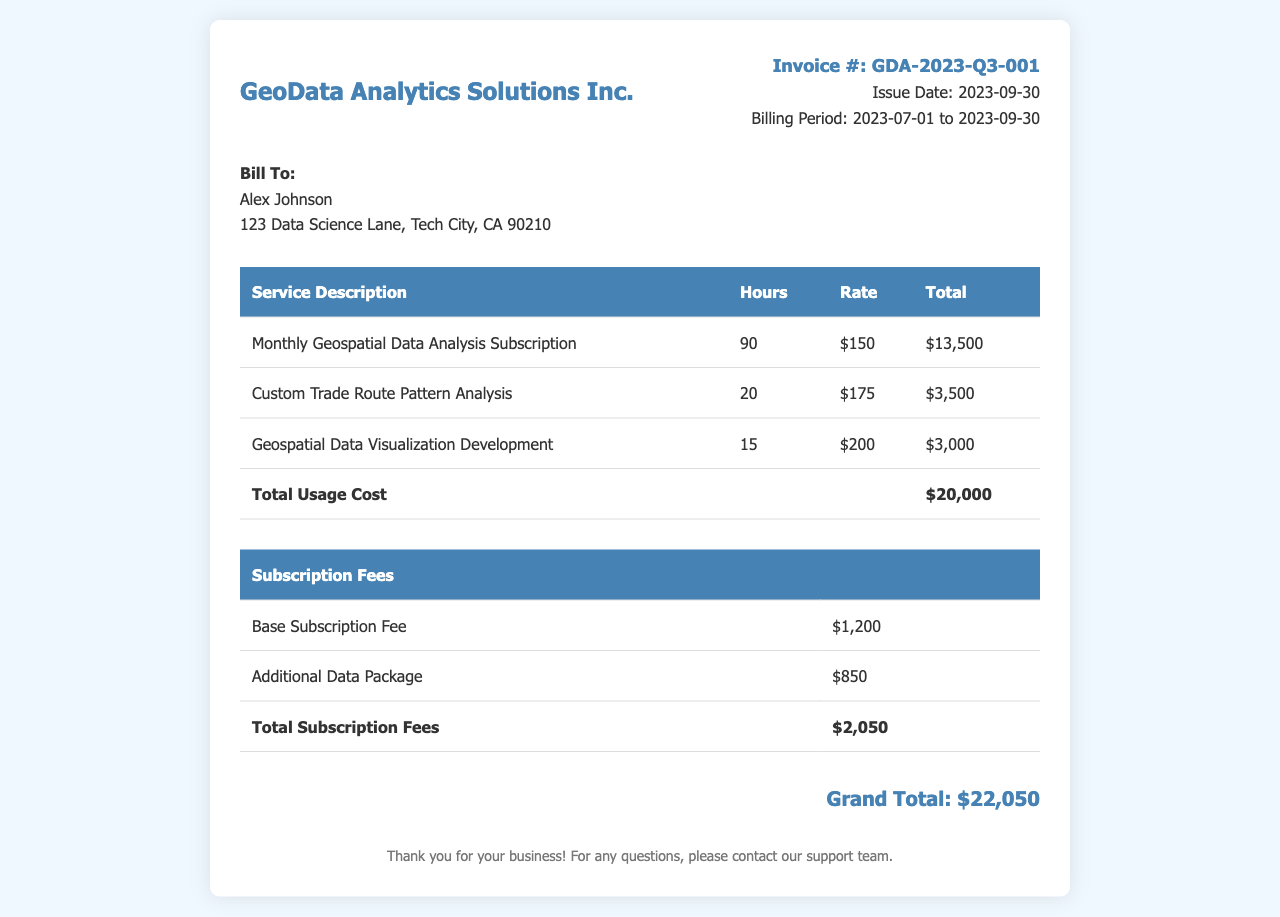What is the invoice number? The invoice number is specifically mentioned in the document under the invoice details section.
Answer: GDA-2023-Q3-001 What is the billing period? The billing period indicates the time frame for which services are being billed, provided in the invoice details section.
Answer: 2023-07-01 to 2023-09-30 How many hours were spent on the custom trade route pattern analysis? The hours for each service are listed in the service details table, highlighting the work performed.
Answer: 20 What is the total usage cost? The total usage cost is the sum of all service totals in the document, shown in the total row of the services table.
Answer: $20,000 What is the total amount for subscription fees? The total subscription fees are calculated from the table listing subscription costs and presented at the end of that section.
Answer: $2,050 How much was charged per hour for geospatial data visualization development? The rate charged for each service is specified in the service details table under the rate column.
Answer: $200 What was the base subscription fee? The base subscription fee is explicitly listed in the subscription fees table.
Answer: $1,200 What is the grand total of the invoice? The grand total combines the total usage cost and subscription fees, and it's displayed prominently at the end of the invoice.
Answer: $22,050 